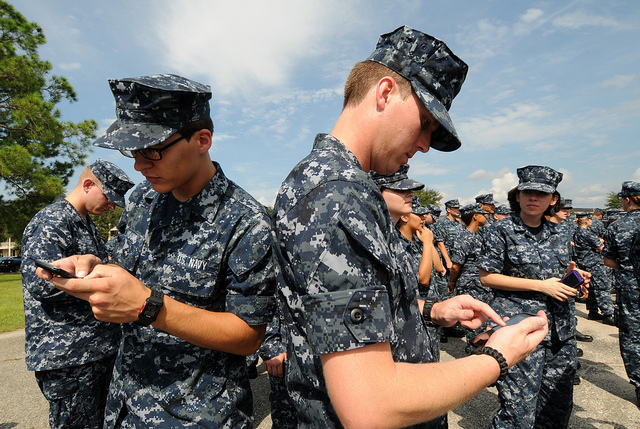Read and extract the text from this image. NAVY 